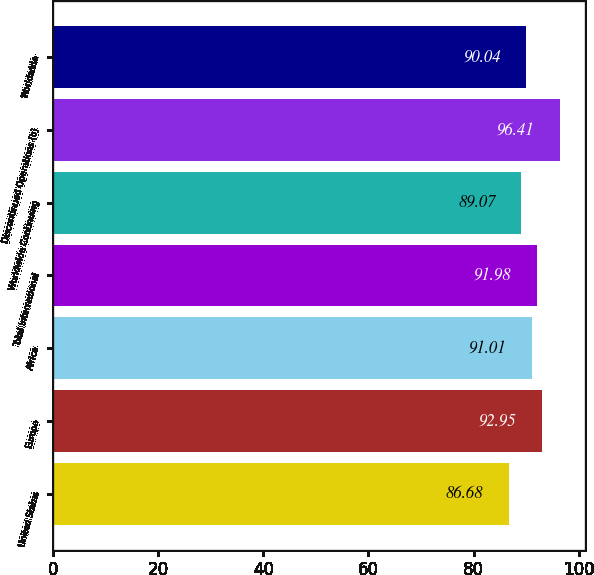Convert chart. <chart><loc_0><loc_0><loc_500><loc_500><bar_chart><fcel>United States<fcel>Europe<fcel>Africa<fcel>Total International<fcel>Worldwide Continuing<fcel>Discontinued Operations (b)<fcel>Worldwide<nl><fcel>86.68<fcel>92.95<fcel>91.01<fcel>91.98<fcel>89.07<fcel>96.41<fcel>90.04<nl></chart> 